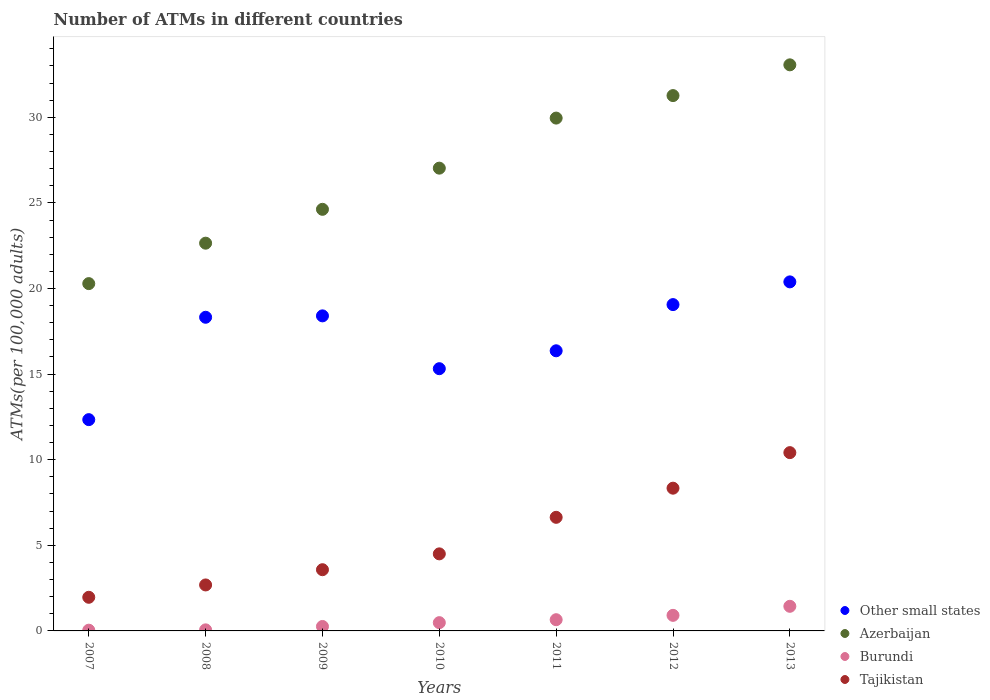How many different coloured dotlines are there?
Keep it short and to the point. 4. Is the number of dotlines equal to the number of legend labels?
Your answer should be very brief. Yes. What is the number of ATMs in Burundi in 2008?
Give a very brief answer. 0.06. Across all years, what is the maximum number of ATMs in Azerbaijan?
Ensure brevity in your answer.  33.06. Across all years, what is the minimum number of ATMs in Other small states?
Offer a very short reply. 12.34. In which year was the number of ATMs in Tajikistan maximum?
Offer a terse response. 2013. In which year was the number of ATMs in Tajikistan minimum?
Provide a succinct answer. 2007. What is the total number of ATMs in Burundi in the graph?
Provide a succinct answer. 3.85. What is the difference between the number of ATMs in Azerbaijan in 2010 and that in 2013?
Your response must be concise. -6.03. What is the difference between the number of ATMs in Burundi in 2011 and the number of ATMs in Azerbaijan in 2010?
Ensure brevity in your answer.  -26.37. What is the average number of ATMs in Burundi per year?
Keep it short and to the point. 0.55. In the year 2013, what is the difference between the number of ATMs in Azerbaijan and number of ATMs in Tajikistan?
Your response must be concise. 22.65. What is the ratio of the number of ATMs in Other small states in 2008 to that in 2010?
Make the answer very short. 1.2. What is the difference between the highest and the second highest number of ATMs in Azerbaijan?
Your answer should be compact. 1.8. What is the difference between the highest and the lowest number of ATMs in Other small states?
Offer a very short reply. 8.05. Is the number of ATMs in Burundi strictly less than the number of ATMs in Azerbaijan over the years?
Your answer should be compact. Yes. How many dotlines are there?
Keep it short and to the point. 4. How many years are there in the graph?
Offer a very short reply. 7. Are the values on the major ticks of Y-axis written in scientific E-notation?
Keep it short and to the point. No. Does the graph contain grids?
Keep it short and to the point. No. How many legend labels are there?
Keep it short and to the point. 4. How are the legend labels stacked?
Offer a very short reply. Vertical. What is the title of the graph?
Your answer should be compact. Number of ATMs in different countries. Does "Guatemala" appear as one of the legend labels in the graph?
Provide a short and direct response. No. What is the label or title of the X-axis?
Offer a terse response. Years. What is the label or title of the Y-axis?
Provide a succinct answer. ATMs(per 100,0 adults). What is the ATMs(per 100,000 adults) in Other small states in 2007?
Make the answer very short. 12.34. What is the ATMs(per 100,000 adults) in Azerbaijan in 2007?
Your answer should be compact. 20.29. What is the ATMs(per 100,000 adults) in Burundi in 2007?
Your answer should be very brief. 0.04. What is the ATMs(per 100,000 adults) in Tajikistan in 2007?
Your response must be concise. 1.96. What is the ATMs(per 100,000 adults) in Other small states in 2008?
Offer a terse response. 18.32. What is the ATMs(per 100,000 adults) of Azerbaijan in 2008?
Provide a succinct answer. 22.65. What is the ATMs(per 100,000 adults) of Burundi in 2008?
Make the answer very short. 0.06. What is the ATMs(per 100,000 adults) of Tajikistan in 2008?
Give a very brief answer. 2.69. What is the ATMs(per 100,000 adults) of Other small states in 2009?
Your answer should be compact. 18.4. What is the ATMs(per 100,000 adults) of Azerbaijan in 2009?
Offer a terse response. 24.63. What is the ATMs(per 100,000 adults) in Burundi in 2009?
Give a very brief answer. 0.26. What is the ATMs(per 100,000 adults) of Tajikistan in 2009?
Your response must be concise. 3.58. What is the ATMs(per 100,000 adults) in Other small states in 2010?
Provide a short and direct response. 15.32. What is the ATMs(per 100,000 adults) of Azerbaijan in 2010?
Give a very brief answer. 27.03. What is the ATMs(per 100,000 adults) in Burundi in 2010?
Provide a short and direct response. 0.48. What is the ATMs(per 100,000 adults) of Tajikistan in 2010?
Give a very brief answer. 4.5. What is the ATMs(per 100,000 adults) of Other small states in 2011?
Ensure brevity in your answer.  16.36. What is the ATMs(per 100,000 adults) in Azerbaijan in 2011?
Keep it short and to the point. 29.95. What is the ATMs(per 100,000 adults) in Burundi in 2011?
Your answer should be very brief. 0.66. What is the ATMs(per 100,000 adults) of Tajikistan in 2011?
Offer a very short reply. 6.64. What is the ATMs(per 100,000 adults) of Other small states in 2012?
Make the answer very short. 19.06. What is the ATMs(per 100,000 adults) of Azerbaijan in 2012?
Your answer should be compact. 31.27. What is the ATMs(per 100,000 adults) in Burundi in 2012?
Offer a terse response. 0.91. What is the ATMs(per 100,000 adults) in Tajikistan in 2012?
Provide a succinct answer. 8.34. What is the ATMs(per 100,000 adults) of Other small states in 2013?
Your answer should be compact. 20.39. What is the ATMs(per 100,000 adults) in Azerbaijan in 2013?
Provide a succinct answer. 33.06. What is the ATMs(per 100,000 adults) of Burundi in 2013?
Provide a short and direct response. 1.44. What is the ATMs(per 100,000 adults) of Tajikistan in 2013?
Keep it short and to the point. 10.41. Across all years, what is the maximum ATMs(per 100,000 adults) in Other small states?
Give a very brief answer. 20.39. Across all years, what is the maximum ATMs(per 100,000 adults) of Azerbaijan?
Ensure brevity in your answer.  33.06. Across all years, what is the maximum ATMs(per 100,000 adults) in Burundi?
Your answer should be compact. 1.44. Across all years, what is the maximum ATMs(per 100,000 adults) of Tajikistan?
Your response must be concise. 10.41. Across all years, what is the minimum ATMs(per 100,000 adults) in Other small states?
Your answer should be compact. 12.34. Across all years, what is the minimum ATMs(per 100,000 adults) of Azerbaijan?
Give a very brief answer. 20.29. Across all years, what is the minimum ATMs(per 100,000 adults) in Burundi?
Your response must be concise. 0.04. Across all years, what is the minimum ATMs(per 100,000 adults) in Tajikistan?
Make the answer very short. 1.96. What is the total ATMs(per 100,000 adults) of Other small states in the graph?
Provide a succinct answer. 120.19. What is the total ATMs(per 100,000 adults) of Azerbaijan in the graph?
Make the answer very short. 188.88. What is the total ATMs(per 100,000 adults) of Burundi in the graph?
Give a very brief answer. 3.85. What is the total ATMs(per 100,000 adults) in Tajikistan in the graph?
Make the answer very short. 38.11. What is the difference between the ATMs(per 100,000 adults) in Other small states in 2007 and that in 2008?
Provide a short and direct response. -5.98. What is the difference between the ATMs(per 100,000 adults) of Azerbaijan in 2007 and that in 2008?
Your response must be concise. -2.36. What is the difference between the ATMs(per 100,000 adults) in Burundi in 2007 and that in 2008?
Ensure brevity in your answer.  -0.02. What is the difference between the ATMs(per 100,000 adults) of Tajikistan in 2007 and that in 2008?
Your answer should be compact. -0.72. What is the difference between the ATMs(per 100,000 adults) of Other small states in 2007 and that in 2009?
Make the answer very short. -6.06. What is the difference between the ATMs(per 100,000 adults) of Azerbaijan in 2007 and that in 2009?
Offer a terse response. -4.34. What is the difference between the ATMs(per 100,000 adults) in Burundi in 2007 and that in 2009?
Ensure brevity in your answer.  -0.22. What is the difference between the ATMs(per 100,000 adults) of Tajikistan in 2007 and that in 2009?
Offer a very short reply. -1.61. What is the difference between the ATMs(per 100,000 adults) of Other small states in 2007 and that in 2010?
Make the answer very short. -2.98. What is the difference between the ATMs(per 100,000 adults) of Azerbaijan in 2007 and that in 2010?
Keep it short and to the point. -6.74. What is the difference between the ATMs(per 100,000 adults) of Burundi in 2007 and that in 2010?
Provide a succinct answer. -0.44. What is the difference between the ATMs(per 100,000 adults) in Tajikistan in 2007 and that in 2010?
Your answer should be very brief. -2.54. What is the difference between the ATMs(per 100,000 adults) of Other small states in 2007 and that in 2011?
Offer a very short reply. -4.02. What is the difference between the ATMs(per 100,000 adults) of Azerbaijan in 2007 and that in 2011?
Offer a very short reply. -9.67. What is the difference between the ATMs(per 100,000 adults) in Burundi in 2007 and that in 2011?
Offer a terse response. -0.61. What is the difference between the ATMs(per 100,000 adults) of Tajikistan in 2007 and that in 2011?
Offer a very short reply. -4.67. What is the difference between the ATMs(per 100,000 adults) of Other small states in 2007 and that in 2012?
Your answer should be compact. -6.72. What is the difference between the ATMs(per 100,000 adults) of Azerbaijan in 2007 and that in 2012?
Offer a very short reply. -10.98. What is the difference between the ATMs(per 100,000 adults) of Burundi in 2007 and that in 2012?
Ensure brevity in your answer.  -0.87. What is the difference between the ATMs(per 100,000 adults) of Tajikistan in 2007 and that in 2012?
Your answer should be very brief. -6.37. What is the difference between the ATMs(per 100,000 adults) in Other small states in 2007 and that in 2013?
Your response must be concise. -8.05. What is the difference between the ATMs(per 100,000 adults) in Azerbaijan in 2007 and that in 2013?
Make the answer very short. -12.78. What is the difference between the ATMs(per 100,000 adults) of Burundi in 2007 and that in 2013?
Give a very brief answer. -1.39. What is the difference between the ATMs(per 100,000 adults) in Tajikistan in 2007 and that in 2013?
Your answer should be very brief. -8.45. What is the difference between the ATMs(per 100,000 adults) of Other small states in 2008 and that in 2009?
Ensure brevity in your answer.  -0.08. What is the difference between the ATMs(per 100,000 adults) in Azerbaijan in 2008 and that in 2009?
Offer a terse response. -1.98. What is the difference between the ATMs(per 100,000 adults) in Burundi in 2008 and that in 2009?
Keep it short and to the point. -0.2. What is the difference between the ATMs(per 100,000 adults) in Tajikistan in 2008 and that in 2009?
Your answer should be compact. -0.89. What is the difference between the ATMs(per 100,000 adults) in Other small states in 2008 and that in 2010?
Make the answer very short. 3. What is the difference between the ATMs(per 100,000 adults) in Azerbaijan in 2008 and that in 2010?
Your answer should be very brief. -4.38. What is the difference between the ATMs(per 100,000 adults) of Burundi in 2008 and that in 2010?
Your response must be concise. -0.42. What is the difference between the ATMs(per 100,000 adults) in Tajikistan in 2008 and that in 2010?
Your answer should be compact. -1.82. What is the difference between the ATMs(per 100,000 adults) in Other small states in 2008 and that in 2011?
Provide a short and direct response. 1.96. What is the difference between the ATMs(per 100,000 adults) in Azerbaijan in 2008 and that in 2011?
Offer a terse response. -7.31. What is the difference between the ATMs(per 100,000 adults) in Burundi in 2008 and that in 2011?
Offer a terse response. -0.59. What is the difference between the ATMs(per 100,000 adults) of Tajikistan in 2008 and that in 2011?
Provide a succinct answer. -3.95. What is the difference between the ATMs(per 100,000 adults) of Other small states in 2008 and that in 2012?
Offer a terse response. -0.74. What is the difference between the ATMs(per 100,000 adults) in Azerbaijan in 2008 and that in 2012?
Offer a very short reply. -8.62. What is the difference between the ATMs(per 100,000 adults) of Burundi in 2008 and that in 2012?
Your response must be concise. -0.85. What is the difference between the ATMs(per 100,000 adults) of Tajikistan in 2008 and that in 2012?
Your response must be concise. -5.65. What is the difference between the ATMs(per 100,000 adults) of Other small states in 2008 and that in 2013?
Your response must be concise. -2.07. What is the difference between the ATMs(per 100,000 adults) in Azerbaijan in 2008 and that in 2013?
Your response must be concise. -10.42. What is the difference between the ATMs(per 100,000 adults) in Burundi in 2008 and that in 2013?
Make the answer very short. -1.38. What is the difference between the ATMs(per 100,000 adults) in Tajikistan in 2008 and that in 2013?
Keep it short and to the point. -7.73. What is the difference between the ATMs(per 100,000 adults) of Other small states in 2009 and that in 2010?
Offer a terse response. 3.09. What is the difference between the ATMs(per 100,000 adults) of Azerbaijan in 2009 and that in 2010?
Make the answer very short. -2.41. What is the difference between the ATMs(per 100,000 adults) in Burundi in 2009 and that in 2010?
Provide a succinct answer. -0.22. What is the difference between the ATMs(per 100,000 adults) of Tajikistan in 2009 and that in 2010?
Ensure brevity in your answer.  -0.93. What is the difference between the ATMs(per 100,000 adults) of Other small states in 2009 and that in 2011?
Provide a short and direct response. 2.04. What is the difference between the ATMs(per 100,000 adults) of Azerbaijan in 2009 and that in 2011?
Offer a terse response. -5.33. What is the difference between the ATMs(per 100,000 adults) in Burundi in 2009 and that in 2011?
Offer a very short reply. -0.4. What is the difference between the ATMs(per 100,000 adults) in Tajikistan in 2009 and that in 2011?
Your answer should be very brief. -3.06. What is the difference between the ATMs(per 100,000 adults) of Other small states in 2009 and that in 2012?
Offer a very short reply. -0.66. What is the difference between the ATMs(per 100,000 adults) in Azerbaijan in 2009 and that in 2012?
Make the answer very short. -6.64. What is the difference between the ATMs(per 100,000 adults) of Burundi in 2009 and that in 2012?
Your answer should be very brief. -0.65. What is the difference between the ATMs(per 100,000 adults) of Tajikistan in 2009 and that in 2012?
Your answer should be compact. -4.76. What is the difference between the ATMs(per 100,000 adults) of Other small states in 2009 and that in 2013?
Keep it short and to the point. -1.99. What is the difference between the ATMs(per 100,000 adults) in Azerbaijan in 2009 and that in 2013?
Your answer should be compact. -8.44. What is the difference between the ATMs(per 100,000 adults) of Burundi in 2009 and that in 2013?
Make the answer very short. -1.18. What is the difference between the ATMs(per 100,000 adults) in Tajikistan in 2009 and that in 2013?
Your answer should be compact. -6.84. What is the difference between the ATMs(per 100,000 adults) in Other small states in 2010 and that in 2011?
Provide a short and direct response. -1.05. What is the difference between the ATMs(per 100,000 adults) in Azerbaijan in 2010 and that in 2011?
Keep it short and to the point. -2.92. What is the difference between the ATMs(per 100,000 adults) of Burundi in 2010 and that in 2011?
Offer a very short reply. -0.17. What is the difference between the ATMs(per 100,000 adults) of Tajikistan in 2010 and that in 2011?
Your response must be concise. -2.13. What is the difference between the ATMs(per 100,000 adults) in Other small states in 2010 and that in 2012?
Offer a terse response. -3.74. What is the difference between the ATMs(per 100,000 adults) of Azerbaijan in 2010 and that in 2012?
Ensure brevity in your answer.  -4.24. What is the difference between the ATMs(per 100,000 adults) in Burundi in 2010 and that in 2012?
Keep it short and to the point. -0.43. What is the difference between the ATMs(per 100,000 adults) of Tajikistan in 2010 and that in 2012?
Offer a very short reply. -3.84. What is the difference between the ATMs(per 100,000 adults) in Other small states in 2010 and that in 2013?
Offer a terse response. -5.07. What is the difference between the ATMs(per 100,000 adults) in Azerbaijan in 2010 and that in 2013?
Keep it short and to the point. -6.03. What is the difference between the ATMs(per 100,000 adults) of Burundi in 2010 and that in 2013?
Ensure brevity in your answer.  -0.95. What is the difference between the ATMs(per 100,000 adults) of Tajikistan in 2010 and that in 2013?
Give a very brief answer. -5.91. What is the difference between the ATMs(per 100,000 adults) of Other small states in 2011 and that in 2012?
Provide a short and direct response. -2.7. What is the difference between the ATMs(per 100,000 adults) of Azerbaijan in 2011 and that in 2012?
Your response must be concise. -1.31. What is the difference between the ATMs(per 100,000 adults) of Burundi in 2011 and that in 2012?
Offer a terse response. -0.25. What is the difference between the ATMs(per 100,000 adults) in Tajikistan in 2011 and that in 2012?
Provide a short and direct response. -1.7. What is the difference between the ATMs(per 100,000 adults) of Other small states in 2011 and that in 2013?
Offer a terse response. -4.03. What is the difference between the ATMs(per 100,000 adults) of Azerbaijan in 2011 and that in 2013?
Keep it short and to the point. -3.11. What is the difference between the ATMs(per 100,000 adults) of Burundi in 2011 and that in 2013?
Offer a terse response. -0.78. What is the difference between the ATMs(per 100,000 adults) of Tajikistan in 2011 and that in 2013?
Give a very brief answer. -3.78. What is the difference between the ATMs(per 100,000 adults) in Other small states in 2012 and that in 2013?
Offer a terse response. -1.33. What is the difference between the ATMs(per 100,000 adults) of Azerbaijan in 2012 and that in 2013?
Offer a very short reply. -1.8. What is the difference between the ATMs(per 100,000 adults) of Burundi in 2012 and that in 2013?
Keep it short and to the point. -0.53. What is the difference between the ATMs(per 100,000 adults) in Tajikistan in 2012 and that in 2013?
Provide a short and direct response. -2.08. What is the difference between the ATMs(per 100,000 adults) in Other small states in 2007 and the ATMs(per 100,000 adults) in Azerbaijan in 2008?
Your answer should be compact. -10.31. What is the difference between the ATMs(per 100,000 adults) in Other small states in 2007 and the ATMs(per 100,000 adults) in Burundi in 2008?
Offer a terse response. 12.28. What is the difference between the ATMs(per 100,000 adults) of Other small states in 2007 and the ATMs(per 100,000 adults) of Tajikistan in 2008?
Your answer should be very brief. 9.66. What is the difference between the ATMs(per 100,000 adults) of Azerbaijan in 2007 and the ATMs(per 100,000 adults) of Burundi in 2008?
Keep it short and to the point. 20.22. What is the difference between the ATMs(per 100,000 adults) of Azerbaijan in 2007 and the ATMs(per 100,000 adults) of Tajikistan in 2008?
Give a very brief answer. 17.6. What is the difference between the ATMs(per 100,000 adults) of Burundi in 2007 and the ATMs(per 100,000 adults) of Tajikistan in 2008?
Your answer should be compact. -2.64. What is the difference between the ATMs(per 100,000 adults) in Other small states in 2007 and the ATMs(per 100,000 adults) in Azerbaijan in 2009?
Provide a succinct answer. -12.28. What is the difference between the ATMs(per 100,000 adults) of Other small states in 2007 and the ATMs(per 100,000 adults) of Burundi in 2009?
Keep it short and to the point. 12.08. What is the difference between the ATMs(per 100,000 adults) in Other small states in 2007 and the ATMs(per 100,000 adults) in Tajikistan in 2009?
Ensure brevity in your answer.  8.77. What is the difference between the ATMs(per 100,000 adults) of Azerbaijan in 2007 and the ATMs(per 100,000 adults) of Burundi in 2009?
Provide a short and direct response. 20.03. What is the difference between the ATMs(per 100,000 adults) of Azerbaijan in 2007 and the ATMs(per 100,000 adults) of Tajikistan in 2009?
Your answer should be compact. 16.71. What is the difference between the ATMs(per 100,000 adults) in Burundi in 2007 and the ATMs(per 100,000 adults) in Tajikistan in 2009?
Provide a short and direct response. -3.53. What is the difference between the ATMs(per 100,000 adults) in Other small states in 2007 and the ATMs(per 100,000 adults) in Azerbaijan in 2010?
Ensure brevity in your answer.  -14.69. What is the difference between the ATMs(per 100,000 adults) in Other small states in 2007 and the ATMs(per 100,000 adults) in Burundi in 2010?
Provide a succinct answer. 11.86. What is the difference between the ATMs(per 100,000 adults) of Other small states in 2007 and the ATMs(per 100,000 adults) of Tajikistan in 2010?
Offer a very short reply. 7.84. What is the difference between the ATMs(per 100,000 adults) of Azerbaijan in 2007 and the ATMs(per 100,000 adults) of Burundi in 2010?
Make the answer very short. 19.8. What is the difference between the ATMs(per 100,000 adults) in Azerbaijan in 2007 and the ATMs(per 100,000 adults) in Tajikistan in 2010?
Keep it short and to the point. 15.79. What is the difference between the ATMs(per 100,000 adults) of Burundi in 2007 and the ATMs(per 100,000 adults) of Tajikistan in 2010?
Ensure brevity in your answer.  -4.46. What is the difference between the ATMs(per 100,000 adults) of Other small states in 2007 and the ATMs(per 100,000 adults) of Azerbaijan in 2011?
Ensure brevity in your answer.  -17.61. What is the difference between the ATMs(per 100,000 adults) in Other small states in 2007 and the ATMs(per 100,000 adults) in Burundi in 2011?
Keep it short and to the point. 11.69. What is the difference between the ATMs(per 100,000 adults) in Other small states in 2007 and the ATMs(per 100,000 adults) in Tajikistan in 2011?
Provide a short and direct response. 5.71. What is the difference between the ATMs(per 100,000 adults) in Azerbaijan in 2007 and the ATMs(per 100,000 adults) in Burundi in 2011?
Provide a succinct answer. 19.63. What is the difference between the ATMs(per 100,000 adults) in Azerbaijan in 2007 and the ATMs(per 100,000 adults) in Tajikistan in 2011?
Provide a short and direct response. 13.65. What is the difference between the ATMs(per 100,000 adults) in Burundi in 2007 and the ATMs(per 100,000 adults) in Tajikistan in 2011?
Provide a short and direct response. -6.59. What is the difference between the ATMs(per 100,000 adults) in Other small states in 2007 and the ATMs(per 100,000 adults) in Azerbaijan in 2012?
Your answer should be very brief. -18.93. What is the difference between the ATMs(per 100,000 adults) of Other small states in 2007 and the ATMs(per 100,000 adults) of Burundi in 2012?
Your answer should be compact. 11.43. What is the difference between the ATMs(per 100,000 adults) of Other small states in 2007 and the ATMs(per 100,000 adults) of Tajikistan in 2012?
Give a very brief answer. 4. What is the difference between the ATMs(per 100,000 adults) of Azerbaijan in 2007 and the ATMs(per 100,000 adults) of Burundi in 2012?
Give a very brief answer. 19.38. What is the difference between the ATMs(per 100,000 adults) of Azerbaijan in 2007 and the ATMs(per 100,000 adults) of Tajikistan in 2012?
Your answer should be compact. 11.95. What is the difference between the ATMs(per 100,000 adults) of Burundi in 2007 and the ATMs(per 100,000 adults) of Tajikistan in 2012?
Provide a succinct answer. -8.29. What is the difference between the ATMs(per 100,000 adults) in Other small states in 2007 and the ATMs(per 100,000 adults) in Azerbaijan in 2013?
Keep it short and to the point. -20.72. What is the difference between the ATMs(per 100,000 adults) in Other small states in 2007 and the ATMs(per 100,000 adults) in Burundi in 2013?
Give a very brief answer. 10.9. What is the difference between the ATMs(per 100,000 adults) in Other small states in 2007 and the ATMs(per 100,000 adults) in Tajikistan in 2013?
Your answer should be compact. 1.93. What is the difference between the ATMs(per 100,000 adults) of Azerbaijan in 2007 and the ATMs(per 100,000 adults) of Burundi in 2013?
Offer a terse response. 18.85. What is the difference between the ATMs(per 100,000 adults) in Azerbaijan in 2007 and the ATMs(per 100,000 adults) in Tajikistan in 2013?
Keep it short and to the point. 9.87. What is the difference between the ATMs(per 100,000 adults) of Burundi in 2007 and the ATMs(per 100,000 adults) of Tajikistan in 2013?
Your answer should be compact. -10.37. What is the difference between the ATMs(per 100,000 adults) of Other small states in 2008 and the ATMs(per 100,000 adults) of Azerbaijan in 2009?
Offer a very short reply. -6.3. What is the difference between the ATMs(per 100,000 adults) in Other small states in 2008 and the ATMs(per 100,000 adults) in Burundi in 2009?
Keep it short and to the point. 18.06. What is the difference between the ATMs(per 100,000 adults) in Other small states in 2008 and the ATMs(per 100,000 adults) in Tajikistan in 2009?
Offer a terse response. 14.74. What is the difference between the ATMs(per 100,000 adults) in Azerbaijan in 2008 and the ATMs(per 100,000 adults) in Burundi in 2009?
Your answer should be very brief. 22.39. What is the difference between the ATMs(per 100,000 adults) in Azerbaijan in 2008 and the ATMs(per 100,000 adults) in Tajikistan in 2009?
Make the answer very short. 19.07. What is the difference between the ATMs(per 100,000 adults) of Burundi in 2008 and the ATMs(per 100,000 adults) of Tajikistan in 2009?
Your answer should be very brief. -3.51. What is the difference between the ATMs(per 100,000 adults) of Other small states in 2008 and the ATMs(per 100,000 adults) of Azerbaijan in 2010?
Provide a short and direct response. -8.71. What is the difference between the ATMs(per 100,000 adults) of Other small states in 2008 and the ATMs(per 100,000 adults) of Burundi in 2010?
Provide a short and direct response. 17.84. What is the difference between the ATMs(per 100,000 adults) of Other small states in 2008 and the ATMs(per 100,000 adults) of Tajikistan in 2010?
Offer a terse response. 13.82. What is the difference between the ATMs(per 100,000 adults) in Azerbaijan in 2008 and the ATMs(per 100,000 adults) in Burundi in 2010?
Give a very brief answer. 22.16. What is the difference between the ATMs(per 100,000 adults) of Azerbaijan in 2008 and the ATMs(per 100,000 adults) of Tajikistan in 2010?
Your answer should be compact. 18.15. What is the difference between the ATMs(per 100,000 adults) of Burundi in 2008 and the ATMs(per 100,000 adults) of Tajikistan in 2010?
Offer a terse response. -4.44. What is the difference between the ATMs(per 100,000 adults) in Other small states in 2008 and the ATMs(per 100,000 adults) in Azerbaijan in 2011?
Your response must be concise. -11.63. What is the difference between the ATMs(per 100,000 adults) in Other small states in 2008 and the ATMs(per 100,000 adults) in Burundi in 2011?
Ensure brevity in your answer.  17.66. What is the difference between the ATMs(per 100,000 adults) of Other small states in 2008 and the ATMs(per 100,000 adults) of Tajikistan in 2011?
Provide a short and direct response. 11.69. What is the difference between the ATMs(per 100,000 adults) of Azerbaijan in 2008 and the ATMs(per 100,000 adults) of Burundi in 2011?
Offer a terse response. 21.99. What is the difference between the ATMs(per 100,000 adults) in Azerbaijan in 2008 and the ATMs(per 100,000 adults) in Tajikistan in 2011?
Give a very brief answer. 16.01. What is the difference between the ATMs(per 100,000 adults) in Burundi in 2008 and the ATMs(per 100,000 adults) in Tajikistan in 2011?
Your answer should be compact. -6.57. What is the difference between the ATMs(per 100,000 adults) in Other small states in 2008 and the ATMs(per 100,000 adults) in Azerbaijan in 2012?
Your answer should be very brief. -12.95. What is the difference between the ATMs(per 100,000 adults) in Other small states in 2008 and the ATMs(per 100,000 adults) in Burundi in 2012?
Your answer should be compact. 17.41. What is the difference between the ATMs(per 100,000 adults) of Other small states in 2008 and the ATMs(per 100,000 adults) of Tajikistan in 2012?
Provide a short and direct response. 9.98. What is the difference between the ATMs(per 100,000 adults) of Azerbaijan in 2008 and the ATMs(per 100,000 adults) of Burundi in 2012?
Ensure brevity in your answer.  21.74. What is the difference between the ATMs(per 100,000 adults) in Azerbaijan in 2008 and the ATMs(per 100,000 adults) in Tajikistan in 2012?
Your answer should be compact. 14.31. What is the difference between the ATMs(per 100,000 adults) in Burundi in 2008 and the ATMs(per 100,000 adults) in Tajikistan in 2012?
Make the answer very short. -8.27. What is the difference between the ATMs(per 100,000 adults) in Other small states in 2008 and the ATMs(per 100,000 adults) in Azerbaijan in 2013?
Make the answer very short. -14.74. What is the difference between the ATMs(per 100,000 adults) of Other small states in 2008 and the ATMs(per 100,000 adults) of Burundi in 2013?
Make the answer very short. 16.88. What is the difference between the ATMs(per 100,000 adults) in Other small states in 2008 and the ATMs(per 100,000 adults) in Tajikistan in 2013?
Provide a short and direct response. 7.91. What is the difference between the ATMs(per 100,000 adults) in Azerbaijan in 2008 and the ATMs(per 100,000 adults) in Burundi in 2013?
Your response must be concise. 21.21. What is the difference between the ATMs(per 100,000 adults) in Azerbaijan in 2008 and the ATMs(per 100,000 adults) in Tajikistan in 2013?
Provide a succinct answer. 12.23. What is the difference between the ATMs(per 100,000 adults) of Burundi in 2008 and the ATMs(per 100,000 adults) of Tajikistan in 2013?
Provide a succinct answer. -10.35. What is the difference between the ATMs(per 100,000 adults) of Other small states in 2009 and the ATMs(per 100,000 adults) of Azerbaijan in 2010?
Your answer should be compact. -8.63. What is the difference between the ATMs(per 100,000 adults) of Other small states in 2009 and the ATMs(per 100,000 adults) of Burundi in 2010?
Offer a terse response. 17.92. What is the difference between the ATMs(per 100,000 adults) in Other small states in 2009 and the ATMs(per 100,000 adults) in Tajikistan in 2010?
Your answer should be very brief. 13.9. What is the difference between the ATMs(per 100,000 adults) in Azerbaijan in 2009 and the ATMs(per 100,000 adults) in Burundi in 2010?
Your answer should be very brief. 24.14. What is the difference between the ATMs(per 100,000 adults) in Azerbaijan in 2009 and the ATMs(per 100,000 adults) in Tajikistan in 2010?
Provide a succinct answer. 20.12. What is the difference between the ATMs(per 100,000 adults) in Burundi in 2009 and the ATMs(per 100,000 adults) in Tajikistan in 2010?
Provide a succinct answer. -4.24. What is the difference between the ATMs(per 100,000 adults) of Other small states in 2009 and the ATMs(per 100,000 adults) of Azerbaijan in 2011?
Keep it short and to the point. -11.55. What is the difference between the ATMs(per 100,000 adults) of Other small states in 2009 and the ATMs(per 100,000 adults) of Burundi in 2011?
Provide a short and direct response. 17.75. What is the difference between the ATMs(per 100,000 adults) in Other small states in 2009 and the ATMs(per 100,000 adults) in Tajikistan in 2011?
Your answer should be very brief. 11.77. What is the difference between the ATMs(per 100,000 adults) in Azerbaijan in 2009 and the ATMs(per 100,000 adults) in Burundi in 2011?
Your answer should be compact. 23.97. What is the difference between the ATMs(per 100,000 adults) of Azerbaijan in 2009 and the ATMs(per 100,000 adults) of Tajikistan in 2011?
Ensure brevity in your answer.  17.99. What is the difference between the ATMs(per 100,000 adults) of Burundi in 2009 and the ATMs(per 100,000 adults) of Tajikistan in 2011?
Your answer should be compact. -6.38. What is the difference between the ATMs(per 100,000 adults) in Other small states in 2009 and the ATMs(per 100,000 adults) in Azerbaijan in 2012?
Your response must be concise. -12.87. What is the difference between the ATMs(per 100,000 adults) in Other small states in 2009 and the ATMs(per 100,000 adults) in Burundi in 2012?
Ensure brevity in your answer.  17.49. What is the difference between the ATMs(per 100,000 adults) in Other small states in 2009 and the ATMs(per 100,000 adults) in Tajikistan in 2012?
Provide a short and direct response. 10.06. What is the difference between the ATMs(per 100,000 adults) of Azerbaijan in 2009 and the ATMs(per 100,000 adults) of Burundi in 2012?
Your response must be concise. 23.72. What is the difference between the ATMs(per 100,000 adults) in Azerbaijan in 2009 and the ATMs(per 100,000 adults) in Tajikistan in 2012?
Keep it short and to the point. 16.29. What is the difference between the ATMs(per 100,000 adults) of Burundi in 2009 and the ATMs(per 100,000 adults) of Tajikistan in 2012?
Ensure brevity in your answer.  -8.08. What is the difference between the ATMs(per 100,000 adults) of Other small states in 2009 and the ATMs(per 100,000 adults) of Azerbaijan in 2013?
Ensure brevity in your answer.  -14.66. What is the difference between the ATMs(per 100,000 adults) of Other small states in 2009 and the ATMs(per 100,000 adults) of Burundi in 2013?
Your answer should be compact. 16.96. What is the difference between the ATMs(per 100,000 adults) of Other small states in 2009 and the ATMs(per 100,000 adults) of Tajikistan in 2013?
Ensure brevity in your answer.  7.99. What is the difference between the ATMs(per 100,000 adults) in Azerbaijan in 2009 and the ATMs(per 100,000 adults) in Burundi in 2013?
Keep it short and to the point. 23.19. What is the difference between the ATMs(per 100,000 adults) of Azerbaijan in 2009 and the ATMs(per 100,000 adults) of Tajikistan in 2013?
Your answer should be very brief. 14.21. What is the difference between the ATMs(per 100,000 adults) of Burundi in 2009 and the ATMs(per 100,000 adults) of Tajikistan in 2013?
Provide a short and direct response. -10.15. What is the difference between the ATMs(per 100,000 adults) in Other small states in 2010 and the ATMs(per 100,000 adults) in Azerbaijan in 2011?
Keep it short and to the point. -14.64. What is the difference between the ATMs(per 100,000 adults) of Other small states in 2010 and the ATMs(per 100,000 adults) of Burundi in 2011?
Give a very brief answer. 14.66. What is the difference between the ATMs(per 100,000 adults) in Other small states in 2010 and the ATMs(per 100,000 adults) in Tajikistan in 2011?
Give a very brief answer. 8.68. What is the difference between the ATMs(per 100,000 adults) in Azerbaijan in 2010 and the ATMs(per 100,000 adults) in Burundi in 2011?
Provide a succinct answer. 26.37. What is the difference between the ATMs(per 100,000 adults) of Azerbaijan in 2010 and the ATMs(per 100,000 adults) of Tajikistan in 2011?
Offer a terse response. 20.39. What is the difference between the ATMs(per 100,000 adults) of Burundi in 2010 and the ATMs(per 100,000 adults) of Tajikistan in 2011?
Offer a very short reply. -6.15. What is the difference between the ATMs(per 100,000 adults) in Other small states in 2010 and the ATMs(per 100,000 adults) in Azerbaijan in 2012?
Your answer should be very brief. -15.95. What is the difference between the ATMs(per 100,000 adults) in Other small states in 2010 and the ATMs(per 100,000 adults) in Burundi in 2012?
Your response must be concise. 14.41. What is the difference between the ATMs(per 100,000 adults) in Other small states in 2010 and the ATMs(per 100,000 adults) in Tajikistan in 2012?
Offer a very short reply. 6.98. What is the difference between the ATMs(per 100,000 adults) of Azerbaijan in 2010 and the ATMs(per 100,000 adults) of Burundi in 2012?
Offer a terse response. 26.12. What is the difference between the ATMs(per 100,000 adults) in Azerbaijan in 2010 and the ATMs(per 100,000 adults) in Tajikistan in 2012?
Provide a short and direct response. 18.69. What is the difference between the ATMs(per 100,000 adults) in Burundi in 2010 and the ATMs(per 100,000 adults) in Tajikistan in 2012?
Provide a short and direct response. -7.85. What is the difference between the ATMs(per 100,000 adults) in Other small states in 2010 and the ATMs(per 100,000 adults) in Azerbaijan in 2013?
Keep it short and to the point. -17.75. What is the difference between the ATMs(per 100,000 adults) of Other small states in 2010 and the ATMs(per 100,000 adults) of Burundi in 2013?
Offer a very short reply. 13.88. What is the difference between the ATMs(per 100,000 adults) of Other small states in 2010 and the ATMs(per 100,000 adults) of Tajikistan in 2013?
Keep it short and to the point. 4.9. What is the difference between the ATMs(per 100,000 adults) in Azerbaijan in 2010 and the ATMs(per 100,000 adults) in Burundi in 2013?
Keep it short and to the point. 25.59. What is the difference between the ATMs(per 100,000 adults) in Azerbaijan in 2010 and the ATMs(per 100,000 adults) in Tajikistan in 2013?
Provide a succinct answer. 16.62. What is the difference between the ATMs(per 100,000 adults) of Burundi in 2010 and the ATMs(per 100,000 adults) of Tajikistan in 2013?
Keep it short and to the point. -9.93. What is the difference between the ATMs(per 100,000 adults) in Other small states in 2011 and the ATMs(per 100,000 adults) in Azerbaijan in 2012?
Ensure brevity in your answer.  -14.91. What is the difference between the ATMs(per 100,000 adults) of Other small states in 2011 and the ATMs(per 100,000 adults) of Burundi in 2012?
Give a very brief answer. 15.45. What is the difference between the ATMs(per 100,000 adults) of Other small states in 2011 and the ATMs(per 100,000 adults) of Tajikistan in 2012?
Ensure brevity in your answer.  8.03. What is the difference between the ATMs(per 100,000 adults) of Azerbaijan in 2011 and the ATMs(per 100,000 adults) of Burundi in 2012?
Provide a short and direct response. 29.04. What is the difference between the ATMs(per 100,000 adults) of Azerbaijan in 2011 and the ATMs(per 100,000 adults) of Tajikistan in 2012?
Offer a very short reply. 21.62. What is the difference between the ATMs(per 100,000 adults) in Burundi in 2011 and the ATMs(per 100,000 adults) in Tajikistan in 2012?
Provide a short and direct response. -7.68. What is the difference between the ATMs(per 100,000 adults) in Other small states in 2011 and the ATMs(per 100,000 adults) in Azerbaijan in 2013?
Ensure brevity in your answer.  -16.7. What is the difference between the ATMs(per 100,000 adults) of Other small states in 2011 and the ATMs(per 100,000 adults) of Burundi in 2013?
Offer a terse response. 14.92. What is the difference between the ATMs(per 100,000 adults) in Other small states in 2011 and the ATMs(per 100,000 adults) in Tajikistan in 2013?
Offer a terse response. 5.95. What is the difference between the ATMs(per 100,000 adults) in Azerbaijan in 2011 and the ATMs(per 100,000 adults) in Burundi in 2013?
Your response must be concise. 28.52. What is the difference between the ATMs(per 100,000 adults) in Azerbaijan in 2011 and the ATMs(per 100,000 adults) in Tajikistan in 2013?
Your answer should be very brief. 19.54. What is the difference between the ATMs(per 100,000 adults) of Burundi in 2011 and the ATMs(per 100,000 adults) of Tajikistan in 2013?
Give a very brief answer. -9.76. What is the difference between the ATMs(per 100,000 adults) in Other small states in 2012 and the ATMs(per 100,000 adults) in Azerbaijan in 2013?
Your answer should be compact. -14. What is the difference between the ATMs(per 100,000 adults) of Other small states in 2012 and the ATMs(per 100,000 adults) of Burundi in 2013?
Keep it short and to the point. 17.62. What is the difference between the ATMs(per 100,000 adults) in Other small states in 2012 and the ATMs(per 100,000 adults) in Tajikistan in 2013?
Your response must be concise. 8.65. What is the difference between the ATMs(per 100,000 adults) in Azerbaijan in 2012 and the ATMs(per 100,000 adults) in Burundi in 2013?
Ensure brevity in your answer.  29.83. What is the difference between the ATMs(per 100,000 adults) in Azerbaijan in 2012 and the ATMs(per 100,000 adults) in Tajikistan in 2013?
Provide a short and direct response. 20.85. What is the difference between the ATMs(per 100,000 adults) in Burundi in 2012 and the ATMs(per 100,000 adults) in Tajikistan in 2013?
Your answer should be compact. -9.5. What is the average ATMs(per 100,000 adults) in Other small states per year?
Keep it short and to the point. 17.17. What is the average ATMs(per 100,000 adults) of Azerbaijan per year?
Your answer should be very brief. 26.98. What is the average ATMs(per 100,000 adults) in Burundi per year?
Your response must be concise. 0.55. What is the average ATMs(per 100,000 adults) in Tajikistan per year?
Offer a terse response. 5.44. In the year 2007, what is the difference between the ATMs(per 100,000 adults) in Other small states and ATMs(per 100,000 adults) in Azerbaijan?
Ensure brevity in your answer.  -7.95. In the year 2007, what is the difference between the ATMs(per 100,000 adults) in Other small states and ATMs(per 100,000 adults) in Burundi?
Your answer should be compact. 12.3. In the year 2007, what is the difference between the ATMs(per 100,000 adults) of Other small states and ATMs(per 100,000 adults) of Tajikistan?
Your answer should be compact. 10.38. In the year 2007, what is the difference between the ATMs(per 100,000 adults) of Azerbaijan and ATMs(per 100,000 adults) of Burundi?
Keep it short and to the point. 20.24. In the year 2007, what is the difference between the ATMs(per 100,000 adults) in Azerbaijan and ATMs(per 100,000 adults) in Tajikistan?
Provide a short and direct response. 18.32. In the year 2007, what is the difference between the ATMs(per 100,000 adults) of Burundi and ATMs(per 100,000 adults) of Tajikistan?
Ensure brevity in your answer.  -1.92. In the year 2008, what is the difference between the ATMs(per 100,000 adults) of Other small states and ATMs(per 100,000 adults) of Azerbaijan?
Ensure brevity in your answer.  -4.33. In the year 2008, what is the difference between the ATMs(per 100,000 adults) of Other small states and ATMs(per 100,000 adults) of Burundi?
Offer a terse response. 18.26. In the year 2008, what is the difference between the ATMs(per 100,000 adults) in Other small states and ATMs(per 100,000 adults) in Tajikistan?
Your answer should be very brief. 15.64. In the year 2008, what is the difference between the ATMs(per 100,000 adults) of Azerbaijan and ATMs(per 100,000 adults) of Burundi?
Provide a succinct answer. 22.59. In the year 2008, what is the difference between the ATMs(per 100,000 adults) in Azerbaijan and ATMs(per 100,000 adults) in Tajikistan?
Your response must be concise. 19.96. In the year 2008, what is the difference between the ATMs(per 100,000 adults) of Burundi and ATMs(per 100,000 adults) of Tajikistan?
Offer a very short reply. -2.62. In the year 2009, what is the difference between the ATMs(per 100,000 adults) of Other small states and ATMs(per 100,000 adults) of Azerbaijan?
Offer a very short reply. -6.22. In the year 2009, what is the difference between the ATMs(per 100,000 adults) in Other small states and ATMs(per 100,000 adults) in Burundi?
Provide a succinct answer. 18.14. In the year 2009, what is the difference between the ATMs(per 100,000 adults) of Other small states and ATMs(per 100,000 adults) of Tajikistan?
Give a very brief answer. 14.83. In the year 2009, what is the difference between the ATMs(per 100,000 adults) of Azerbaijan and ATMs(per 100,000 adults) of Burundi?
Offer a terse response. 24.37. In the year 2009, what is the difference between the ATMs(per 100,000 adults) in Azerbaijan and ATMs(per 100,000 adults) in Tajikistan?
Offer a very short reply. 21.05. In the year 2009, what is the difference between the ATMs(per 100,000 adults) in Burundi and ATMs(per 100,000 adults) in Tajikistan?
Ensure brevity in your answer.  -3.32. In the year 2010, what is the difference between the ATMs(per 100,000 adults) of Other small states and ATMs(per 100,000 adults) of Azerbaijan?
Keep it short and to the point. -11.71. In the year 2010, what is the difference between the ATMs(per 100,000 adults) of Other small states and ATMs(per 100,000 adults) of Burundi?
Provide a short and direct response. 14.83. In the year 2010, what is the difference between the ATMs(per 100,000 adults) in Other small states and ATMs(per 100,000 adults) in Tajikistan?
Provide a short and direct response. 10.82. In the year 2010, what is the difference between the ATMs(per 100,000 adults) of Azerbaijan and ATMs(per 100,000 adults) of Burundi?
Keep it short and to the point. 26.55. In the year 2010, what is the difference between the ATMs(per 100,000 adults) in Azerbaijan and ATMs(per 100,000 adults) in Tajikistan?
Give a very brief answer. 22.53. In the year 2010, what is the difference between the ATMs(per 100,000 adults) in Burundi and ATMs(per 100,000 adults) in Tajikistan?
Give a very brief answer. -4.02. In the year 2011, what is the difference between the ATMs(per 100,000 adults) of Other small states and ATMs(per 100,000 adults) of Azerbaijan?
Offer a terse response. -13.59. In the year 2011, what is the difference between the ATMs(per 100,000 adults) of Other small states and ATMs(per 100,000 adults) of Burundi?
Offer a terse response. 15.71. In the year 2011, what is the difference between the ATMs(per 100,000 adults) in Other small states and ATMs(per 100,000 adults) in Tajikistan?
Your answer should be compact. 9.73. In the year 2011, what is the difference between the ATMs(per 100,000 adults) of Azerbaijan and ATMs(per 100,000 adults) of Burundi?
Give a very brief answer. 29.3. In the year 2011, what is the difference between the ATMs(per 100,000 adults) of Azerbaijan and ATMs(per 100,000 adults) of Tajikistan?
Keep it short and to the point. 23.32. In the year 2011, what is the difference between the ATMs(per 100,000 adults) of Burundi and ATMs(per 100,000 adults) of Tajikistan?
Give a very brief answer. -5.98. In the year 2012, what is the difference between the ATMs(per 100,000 adults) in Other small states and ATMs(per 100,000 adults) in Azerbaijan?
Keep it short and to the point. -12.21. In the year 2012, what is the difference between the ATMs(per 100,000 adults) of Other small states and ATMs(per 100,000 adults) of Burundi?
Provide a succinct answer. 18.15. In the year 2012, what is the difference between the ATMs(per 100,000 adults) in Other small states and ATMs(per 100,000 adults) in Tajikistan?
Your answer should be very brief. 10.72. In the year 2012, what is the difference between the ATMs(per 100,000 adults) of Azerbaijan and ATMs(per 100,000 adults) of Burundi?
Ensure brevity in your answer.  30.36. In the year 2012, what is the difference between the ATMs(per 100,000 adults) in Azerbaijan and ATMs(per 100,000 adults) in Tajikistan?
Provide a succinct answer. 22.93. In the year 2012, what is the difference between the ATMs(per 100,000 adults) of Burundi and ATMs(per 100,000 adults) of Tajikistan?
Your answer should be compact. -7.43. In the year 2013, what is the difference between the ATMs(per 100,000 adults) of Other small states and ATMs(per 100,000 adults) of Azerbaijan?
Offer a terse response. -12.68. In the year 2013, what is the difference between the ATMs(per 100,000 adults) in Other small states and ATMs(per 100,000 adults) in Burundi?
Offer a very short reply. 18.95. In the year 2013, what is the difference between the ATMs(per 100,000 adults) of Other small states and ATMs(per 100,000 adults) of Tajikistan?
Offer a very short reply. 9.97. In the year 2013, what is the difference between the ATMs(per 100,000 adults) of Azerbaijan and ATMs(per 100,000 adults) of Burundi?
Provide a short and direct response. 31.63. In the year 2013, what is the difference between the ATMs(per 100,000 adults) of Azerbaijan and ATMs(per 100,000 adults) of Tajikistan?
Your response must be concise. 22.65. In the year 2013, what is the difference between the ATMs(per 100,000 adults) of Burundi and ATMs(per 100,000 adults) of Tajikistan?
Offer a terse response. -8.98. What is the ratio of the ATMs(per 100,000 adults) of Other small states in 2007 to that in 2008?
Ensure brevity in your answer.  0.67. What is the ratio of the ATMs(per 100,000 adults) of Azerbaijan in 2007 to that in 2008?
Make the answer very short. 0.9. What is the ratio of the ATMs(per 100,000 adults) in Burundi in 2007 to that in 2008?
Your response must be concise. 0.69. What is the ratio of the ATMs(per 100,000 adults) of Tajikistan in 2007 to that in 2008?
Your answer should be very brief. 0.73. What is the ratio of the ATMs(per 100,000 adults) in Other small states in 2007 to that in 2009?
Your response must be concise. 0.67. What is the ratio of the ATMs(per 100,000 adults) in Azerbaijan in 2007 to that in 2009?
Offer a terse response. 0.82. What is the ratio of the ATMs(per 100,000 adults) of Burundi in 2007 to that in 2009?
Your answer should be compact. 0.17. What is the ratio of the ATMs(per 100,000 adults) of Tajikistan in 2007 to that in 2009?
Your answer should be compact. 0.55. What is the ratio of the ATMs(per 100,000 adults) of Other small states in 2007 to that in 2010?
Ensure brevity in your answer.  0.81. What is the ratio of the ATMs(per 100,000 adults) of Azerbaijan in 2007 to that in 2010?
Offer a very short reply. 0.75. What is the ratio of the ATMs(per 100,000 adults) in Burundi in 2007 to that in 2010?
Offer a very short reply. 0.09. What is the ratio of the ATMs(per 100,000 adults) in Tajikistan in 2007 to that in 2010?
Your answer should be compact. 0.44. What is the ratio of the ATMs(per 100,000 adults) in Other small states in 2007 to that in 2011?
Your response must be concise. 0.75. What is the ratio of the ATMs(per 100,000 adults) of Azerbaijan in 2007 to that in 2011?
Keep it short and to the point. 0.68. What is the ratio of the ATMs(per 100,000 adults) in Burundi in 2007 to that in 2011?
Offer a very short reply. 0.07. What is the ratio of the ATMs(per 100,000 adults) of Tajikistan in 2007 to that in 2011?
Your response must be concise. 0.3. What is the ratio of the ATMs(per 100,000 adults) of Other small states in 2007 to that in 2012?
Ensure brevity in your answer.  0.65. What is the ratio of the ATMs(per 100,000 adults) of Azerbaijan in 2007 to that in 2012?
Keep it short and to the point. 0.65. What is the ratio of the ATMs(per 100,000 adults) in Burundi in 2007 to that in 2012?
Your answer should be compact. 0.05. What is the ratio of the ATMs(per 100,000 adults) of Tajikistan in 2007 to that in 2012?
Your answer should be very brief. 0.24. What is the ratio of the ATMs(per 100,000 adults) in Other small states in 2007 to that in 2013?
Make the answer very short. 0.61. What is the ratio of the ATMs(per 100,000 adults) in Azerbaijan in 2007 to that in 2013?
Your answer should be very brief. 0.61. What is the ratio of the ATMs(per 100,000 adults) in Burundi in 2007 to that in 2013?
Provide a short and direct response. 0.03. What is the ratio of the ATMs(per 100,000 adults) in Tajikistan in 2007 to that in 2013?
Provide a short and direct response. 0.19. What is the ratio of the ATMs(per 100,000 adults) of Other small states in 2008 to that in 2009?
Your answer should be compact. 1. What is the ratio of the ATMs(per 100,000 adults) of Azerbaijan in 2008 to that in 2009?
Offer a very short reply. 0.92. What is the ratio of the ATMs(per 100,000 adults) in Burundi in 2008 to that in 2009?
Your answer should be very brief. 0.24. What is the ratio of the ATMs(per 100,000 adults) of Tajikistan in 2008 to that in 2009?
Your answer should be compact. 0.75. What is the ratio of the ATMs(per 100,000 adults) in Other small states in 2008 to that in 2010?
Offer a very short reply. 1.2. What is the ratio of the ATMs(per 100,000 adults) in Azerbaijan in 2008 to that in 2010?
Make the answer very short. 0.84. What is the ratio of the ATMs(per 100,000 adults) of Burundi in 2008 to that in 2010?
Provide a succinct answer. 0.13. What is the ratio of the ATMs(per 100,000 adults) in Tajikistan in 2008 to that in 2010?
Your response must be concise. 0.6. What is the ratio of the ATMs(per 100,000 adults) of Other small states in 2008 to that in 2011?
Provide a short and direct response. 1.12. What is the ratio of the ATMs(per 100,000 adults) of Azerbaijan in 2008 to that in 2011?
Keep it short and to the point. 0.76. What is the ratio of the ATMs(per 100,000 adults) of Burundi in 2008 to that in 2011?
Your answer should be compact. 0.1. What is the ratio of the ATMs(per 100,000 adults) in Tajikistan in 2008 to that in 2011?
Give a very brief answer. 0.4. What is the ratio of the ATMs(per 100,000 adults) in Other small states in 2008 to that in 2012?
Your answer should be compact. 0.96. What is the ratio of the ATMs(per 100,000 adults) of Azerbaijan in 2008 to that in 2012?
Your answer should be very brief. 0.72. What is the ratio of the ATMs(per 100,000 adults) in Burundi in 2008 to that in 2012?
Your answer should be very brief. 0.07. What is the ratio of the ATMs(per 100,000 adults) of Tajikistan in 2008 to that in 2012?
Make the answer very short. 0.32. What is the ratio of the ATMs(per 100,000 adults) of Other small states in 2008 to that in 2013?
Your response must be concise. 0.9. What is the ratio of the ATMs(per 100,000 adults) of Azerbaijan in 2008 to that in 2013?
Provide a succinct answer. 0.69. What is the ratio of the ATMs(per 100,000 adults) in Burundi in 2008 to that in 2013?
Offer a very short reply. 0.04. What is the ratio of the ATMs(per 100,000 adults) in Tajikistan in 2008 to that in 2013?
Keep it short and to the point. 0.26. What is the ratio of the ATMs(per 100,000 adults) of Other small states in 2009 to that in 2010?
Offer a terse response. 1.2. What is the ratio of the ATMs(per 100,000 adults) in Azerbaijan in 2009 to that in 2010?
Ensure brevity in your answer.  0.91. What is the ratio of the ATMs(per 100,000 adults) in Burundi in 2009 to that in 2010?
Offer a very short reply. 0.54. What is the ratio of the ATMs(per 100,000 adults) in Tajikistan in 2009 to that in 2010?
Your response must be concise. 0.79. What is the ratio of the ATMs(per 100,000 adults) in Other small states in 2009 to that in 2011?
Your response must be concise. 1.12. What is the ratio of the ATMs(per 100,000 adults) in Azerbaijan in 2009 to that in 2011?
Your answer should be very brief. 0.82. What is the ratio of the ATMs(per 100,000 adults) of Burundi in 2009 to that in 2011?
Your answer should be very brief. 0.4. What is the ratio of the ATMs(per 100,000 adults) in Tajikistan in 2009 to that in 2011?
Make the answer very short. 0.54. What is the ratio of the ATMs(per 100,000 adults) in Other small states in 2009 to that in 2012?
Provide a short and direct response. 0.97. What is the ratio of the ATMs(per 100,000 adults) of Azerbaijan in 2009 to that in 2012?
Your response must be concise. 0.79. What is the ratio of the ATMs(per 100,000 adults) of Burundi in 2009 to that in 2012?
Ensure brevity in your answer.  0.29. What is the ratio of the ATMs(per 100,000 adults) of Tajikistan in 2009 to that in 2012?
Give a very brief answer. 0.43. What is the ratio of the ATMs(per 100,000 adults) in Other small states in 2009 to that in 2013?
Your answer should be very brief. 0.9. What is the ratio of the ATMs(per 100,000 adults) in Azerbaijan in 2009 to that in 2013?
Keep it short and to the point. 0.74. What is the ratio of the ATMs(per 100,000 adults) of Burundi in 2009 to that in 2013?
Make the answer very short. 0.18. What is the ratio of the ATMs(per 100,000 adults) in Tajikistan in 2009 to that in 2013?
Give a very brief answer. 0.34. What is the ratio of the ATMs(per 100,000 adults) in Other small states in 2010 to that in 2011?
Give a very brief answer. 0.94. What is the ratio of the ATMs(per 100,000 adults) of Azerbaijan in 2010 to that in 2011?
Give a very brief answer. 0.9. What is the ratio of the ATMs(per 100,000 adults) in Burundi in 2010 to that in 2011?
Give a very brief answer. 0.74. What is the ratio of the ATMs(per 100,000 adults) of Tajikistan in 2010 to that in 2011?
Offer a very short reply. 0.68. What is the ratio of the ATMs(per 100,000 adults) of Other small states in 2010 to that in 2012?
Your answer should be very brief. 0.8. What is the ratio of the ATMs(per 100,000 adults) in Azerbaijan in 2010 to that in 2012?
Provide a short and direct response. 0.86. What is the ratio of the ATMs(per 100,000 adults) of Burundi in 2010 to that in 2012?
Your answer should be very brief. 0.53. What is the ratio of the ATMs(per 100,000 adults) in Tajikistan in 2010 to that in 2012?
Offer a terse response. 0.54. What is the ratio of the ATMs(per 100,000 adults) in Other small states in 2010 to that in 2013?
Offer a very short reply. 0.75. What is the ratio of the ATMs(per 100,000 adults) of Azerbaijan in 2010 to that in 2013?
Keep it short and to the point. 0.82. What is the ratio of the ATMs(per 100,000 adults) of Burundi in 2010 to that in 2013?
Provide a short and direct response. 0.34. What is the ratio of the ATMs(per 100,000 adults) of Tajikistan in 2010 to that in 2013?
Make the answer very short. 0.43. What is the ratio of the ATMs(per 100,000 adults) in Other small states in 2011 to that in 2012?
Your response must be concise. 0.86. What is the ratio of the ATMs(per 100,000 adults) in Azerbaijan in 2011 to that in 2012?
Offer a very short reply. 0.96. What is the ratio of the ATMs(per 100,000 adults) of Burundi in 2011 to that in 2012?
Keep it short and to the point. 0.72. What is the ratio of the ATMs(per 100,000 adults) of Tajikistan in 2011 to that in 2012?
Your response must be concise. 0.8. What is the ratio of the ATMs(per 100,000 adults) of Other small states in 2011 to that in 2013?
Give a very brief answer. 0.8. What is the ratio of the ATMs(per 100,000 adults) of Azerbaijan in 2011 to that in 2013?
Make the answer very short. 0.91. What is the ratio of the ATMs(per 100,000 adults) of Burundi in 2011 to that in 2013?
Make the answer very short. 0.46. What is the ratio of the ATMs(per 100,000 adults) of Tajikistan in 2011 to that in 2013?
Provide a short and direct response. 0.64. What is the ratio of the ATMs(per 100,000 adults) of Other small states in 2012 to that in 2013?
Provide a short and direct response. 0.93. What is the ratio of the ATMs(per 100,000 adults) in Azerbaijan in 2012 to that in 2013?
Give a very brief answer. 0.95. What is the ratio of the ATMs(per 100,000 adults) in Burundi in 2012 to that in 2013?
Your answer should be compact. 0.63. What is the ratio of the ATMs(per 100,000 adults) in Tajikistan in 2012 to that in 2013?
Provide a short and direct response. 0.8. What is the difference between the highest and the second highest ATMs(per 100,000 adults) in Other small states?
Offer a very short reply. 1.33. What is the difference between the highest and the second highest ATMs(per 100,000 adults) of Azerbaijan?
Make the answer very short. 1.8. What is the difference between the highest and the second highest ATMs(per 100,000 adults) in Burundi?
Make the answer very short. 0.53. What is the difference between the highest and the second highest ATMs(per 100,000 adults) of Tajikistan?
Your answer should be very brief. 2.08. What is the difference between the highest and the lowest ATMs(per 100,000 adults) of Other small states?
Offer a terse response. 8.05. What is the difference between the highest and the lowest ATMs(per 100,000 adults) in Azerbaijan?
Ensure brevity in your answer.  12.78. What is the difference between the highest and the lowest ATMs(per 100,000 adults) of Burundi?
Provide a short and direct response. 1.39. What is the difference between the highest and the lowest ATMs(per 100,000 adults) of Tajikistan?
Your response must be concise. 8.45. 